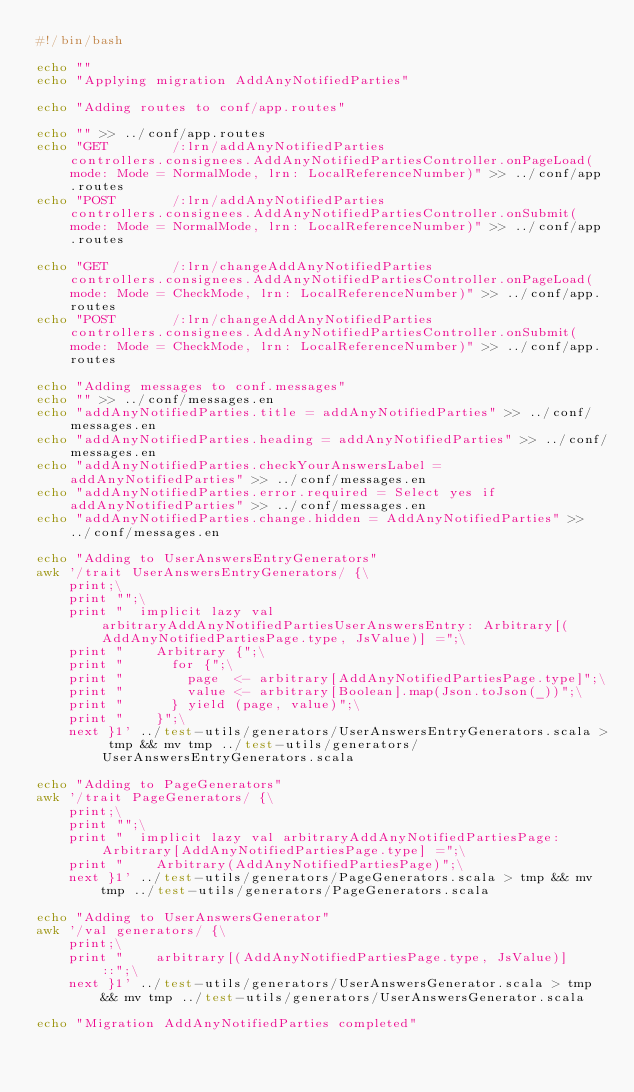<code> <loc_0><loc_0><loc_500><loc_500><_Bash_>#!/bin/bash

echo ""
echo "Applying migration AddAnyNotifiedParties"

echo "Adding routes to conf/app.routes"

echo "" >> ../conf/app.routes
echo "GET        /:lrn/addAnyNotifiedParties                        controllers.consignees.AddAnyNotifiedPartiesController.onPageLoad(mode: Mode = NormalMode, lrn: LocalReferenceNumber)" >> ../conf/app.routes
echo "POST       /:lrn/addAnyNotifiedParties                        controllers.consignees.AddAnyNotifiedPartiesController.onSubmit(mode: Mode = NormalMode, lrn: LocalReferenceNumber)" >> ../conf/app.routes

echo "GET        /:lrn/changeAddAnyNotifiedParties                  controllers.consignees.AddAnyNotifiedPartiesController.onPageLoad(mode: Mode = CheckMode, lrn: LocalReferenceNumber)" >> ../conf/app.routes
echo "POST       /:lrn/changeAddAnyNotifiedParties                  controllers.consignees.AddAnyNotifiedPartiesController.onSubmit(mode: Mode = CheckMode, lrn: LocalReferenceNumber)" >> ../conf/app.routes

echo "Adding messages to conf.messages"
echo "" >> ../conf/messages.en
echo "addAnyNotifiedParties.title = addAnyNotifiedParties" >> ../conf/messages.en
echo "addAnyNotifiedParties.heading = addAnyNotifiedParties" >> ../conf/messages.en
echo "addAnyNotifiedParties.checkYourAnswersLabel = addAnyNotifiedParties" >> ../conf/messages.en
echo "addAnyNotifiedParties.error.required = Select yes if addAnyNotifiedParties" >> ../conf/messages.en
echo "addAnyNotifiedParties.change.hidden = AddAnyNotifiedParties" >> ../conf/messages.en

echo "Adding to UserAnswersEntryGenerators"
awk '/trait UserAnswersEntryGenerators/ {\
    print;\
    print "";\
    print "  implicit lazy val arbitraryAddAnyNotifiedPartiesUserAnswersEntry: Arbitrary[(AddAnyNotifiedPartiesPage.type, JsValue)] =";\
    print "    Arbitrary {";\
    print "      for {";\
    print "        page  <- arbitrary[AddAnyNotifiedPartiesPage.type]";\
    print "        value <- arbitrary[Boolean].map(Json.toJson(_))";\
    print "      } yield (page, value)";\
    print "    }";\
    next }1' ../test-utils/generators/UserAnswersEntryGenerators.scala > tmp && mv tmp ../test-utils/generators/UserAnswersEntryGenerators.scala

echo "Adding to PageGenerators"
awk '/trait PageGenerators/ {\
    print;\
    print "";\
    print "  implicit lazy val arbitraryAddAnyNotifiedPartiesPage: Arbitrary[AddAnyNotifiedPartiesPage.type] =";\
    print "    Arbitrary(AddAnyNotifiedPartiesPage)";\
    next }1' ../test-utils/generators/PageGenerators.scala > tmp && mv tmp ../test-utils/generators/PageGenerators.scala

echo "Adding to UserAnswersGenerator"
awk '/val generators/ {\
    print;\
    print "    arbitrary[(AddAnyNotifiedPartiesPage.type, JsValue)] ::";\
    next }1' ../test-utils/generators/UserAnswersGenerator.scala > tmp && mv tmp ../test-utils/generators/UserAnswersGenerator.scala

echo "Migration AddAnyNotifiedParties completed"
</code> 